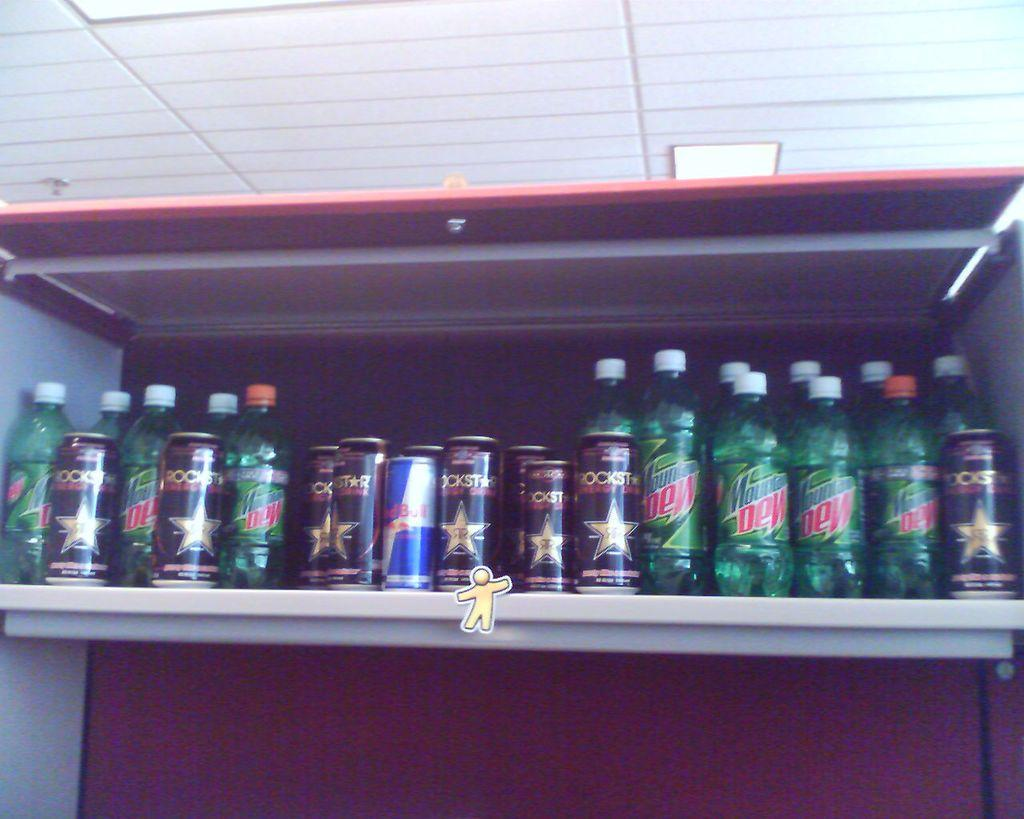Provide a one-sentence caption for the provided image. A shelf contains Mountain Dew, Rockstar and Red Bull. 